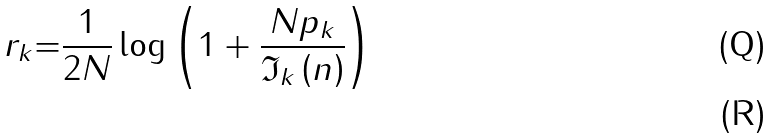Convert formula to latex. <formula><loc_0><loc_0><loc_500><loc_500>r _ { k } { = } \frac { 1 } { 2 N } \log { \left ( 1 + \frac { N p _ { k } } { \mathfrak { I } _ { k } \left ( n \right ) } \right ) } \\</formula> 